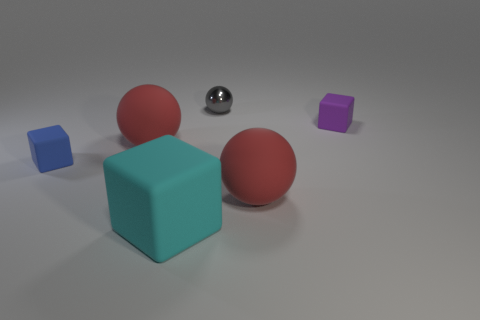Can you compare the textures of the objects in this image? Certainly! The blue and purple blocks have a matte finish with a slightly rough texture, while the two red cubes appear to have a rubbery texture. The silver sphere stands out with its smooth, highly reflective glossy surface. Are there any patterns or consistencies in the arrangement of the objects? The objects are arranged with ample space between them, suggesting a deliberate placement rather than a random scattering. It appears that there's a balance in terms of color distribution and shapes, providing an aesthetically pleasing composition. 